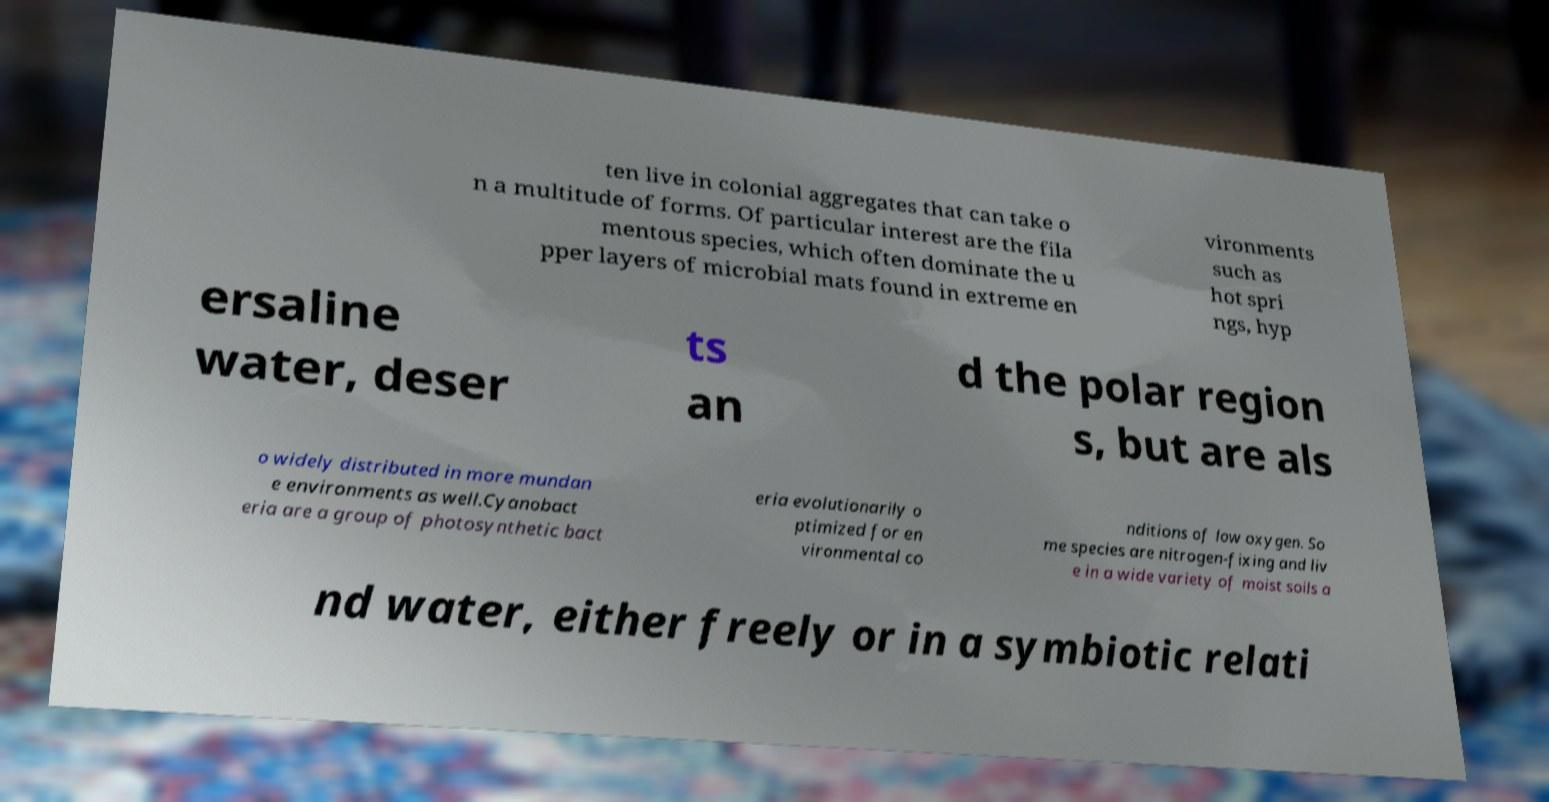Can you read and provide the text displayed in the image?This photo seems to have some interesting text. Can you extract and type it out for me? ten live in colonial aggregates that can take o n a multitude of forms. Of particular interest are the fila mentous species, which often dominate the u pper layers of microbial mats found in extreme en vironments such as hot spri ngs, hyp ersaline water, deser ts an d the polar region s, but are als o widely distributed in more mundan e environments as well.Cyanobact eria are a group of photosynthetic bact eria evolutionarily o ptimized for en vironmental co nditions of low oxygen. So me species are nitrogen-fixing and liv e in a wide variety of moist soils a nd water, either freely or in a symbiotic relati 